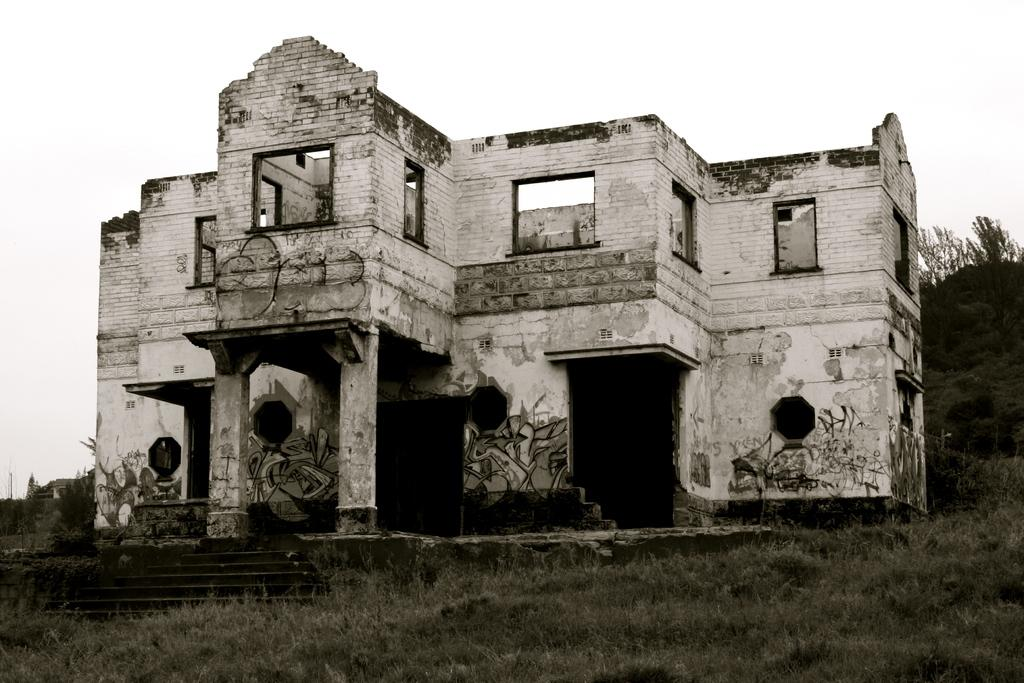What type of structure is present in the picture? There is a building in the picture. What type of vegetation can be seen in the picture? There is grass and trees in the picture. What part of the natural environment is visible in the picture? The sky is visible in the background of the picture. What type of box is being used to frame the baby in the picture? There is no box or baby present in the image; it features a building, grass, trees, and the sky. 